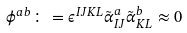Convert formula to latex. <formula><loc_0><loc_0><loc_500><loc_500>\phi ^ { a b } \colon = \epsilon ^ { I J K L } \tilde { \alpha } _ { I J } ^ { a } \tilde { \alpha } ^ { b } _ { K L } \approx 0</formula> 